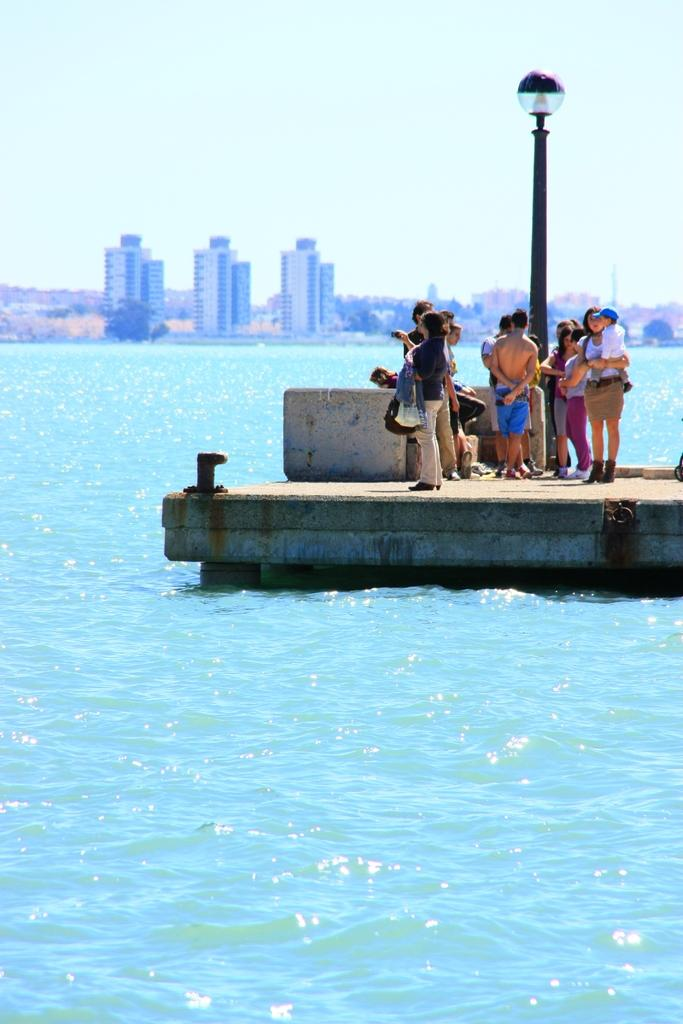How many people are in the image? There is a group of people in the image. What are the people doing in the image? The people are standing on a path. Can you describe the woman in the image? The woman is holding a kid. What can be seen in the image besides the people? There is a pole with a light, water, buildings, trees, and the sky visible in the image. What type of war is being fought in the image? There is no war present in the image; it features a group of people standing on a path with a woman holding a kid. What type of stem is visible in the image? There is no stem present in the image. 